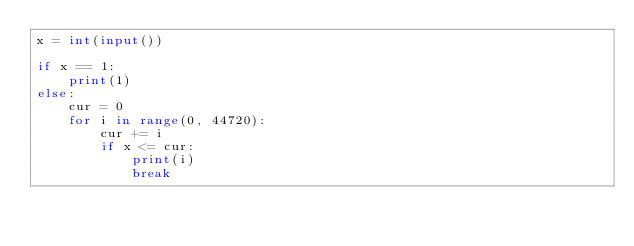<code> <loc_0><loc_0><loc_500><loc_500><_Python_>x = int(input())

if x == 1:
    print(1)
else:
    cur = 0
    for i in range(0, 44720):
        cur += i
        if x <= cur:
            print(i)
            break</code> 